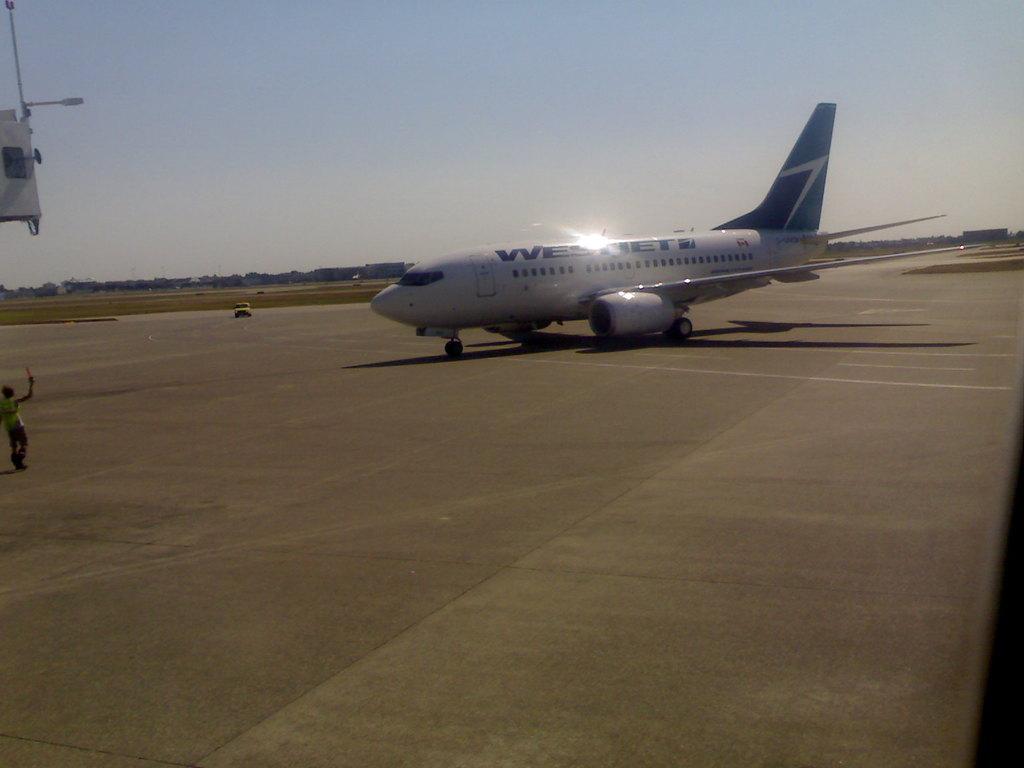What is the name of the airline?
Provide a succinct answer. Westjet. 